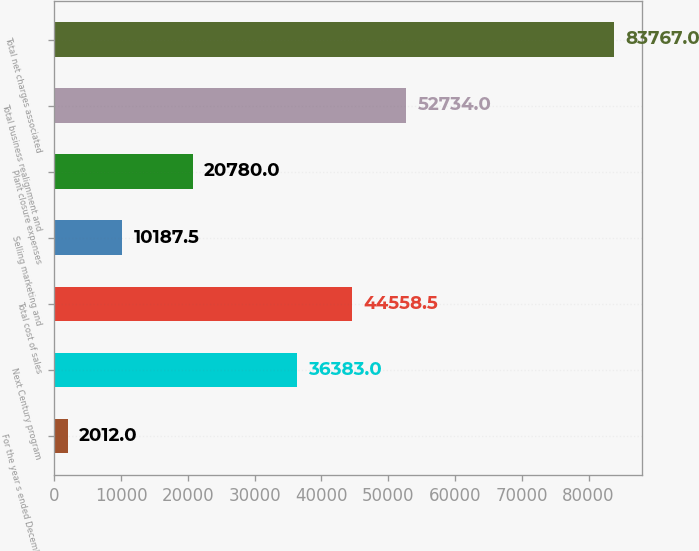<chart> <loc_0><loc_0><loc_500><loc_500><bar_chart><fcel>For the year s ended December<fcel>Next Century program<fcel>Total cost of sales<fcel>Selling marketing and<fcel>Plant closure expenses<fcel>Total business realignment and<fcel>Total net charges associated<nl><fcel>2012<fcel>36383<fcel>44558.5<fcel>10187.5<fcel>20780<fcel>52734<fcel>83767<nl></chart> 